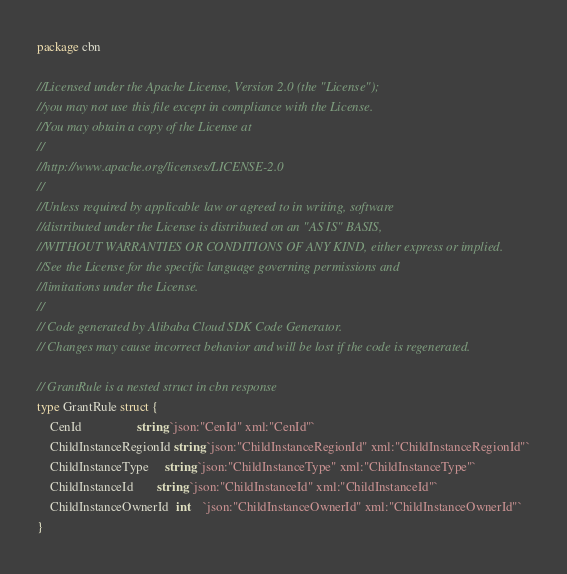<code> <loc_0><loc_0><loc_500><loc_500><_Go_>package cbn

//Licensed under the Apache License, Version 2.0 (the "License");
//you may not use this file except in compliance with the License.
//You may obtain a copy of the License at
//
//http://www.apache.org/licenses/LICENSE-2.0
//
//Unless required by applicable law or agreed to in writing, software
//distributed under the License is distributed on an "AS IS" BASIS,
//WITHOUT WARRANTIES OR CONDITIONS OF ANY KIND, either express or implied.
//See the License for the specific language governing permissions and
//limitations under the License.
//
// Code generated by Alibaba Cloud SDK Code Generator.
// Changes may cause incorrect behavior and will be lost if the code is regenerated.

// GrantRule is a nested struct in cbn response
type GrantRule struct {
	CenId                 string `json:"CenId" xml:"CenId"`
	ChildInstanceRegionId string `json:"ChildInstanceRegionId" xml:"ChildInstanceRegionId"`
	ChildInstanceType     string `json:"ChildInstanceType" xml:"ChildInstanceType"`
	ChildInstanceId       string `json:"ChildInstanceId" xml:"ChildInstanceId"`
	ChildInstanceOwnerId  int    `json:"ChildInstanceOwnerId" xml:"ChildInstanceOwnerId"`
}
</code> 